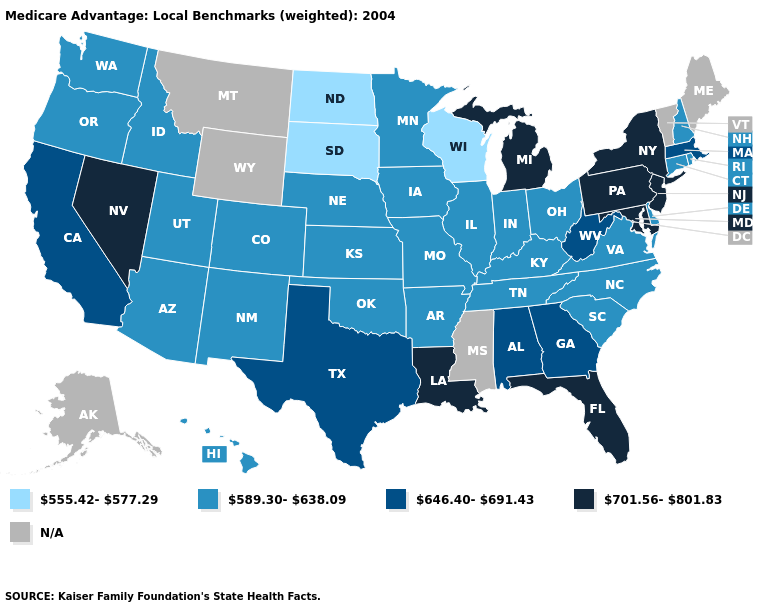What is the highest value in the USA?
Be succinct. 701.56-801.83. Which states have the lowest value in the MidWest?
Keep it brief. North Dakota, South Dakota, Wisconsin. Among the states that border Louisiana , which have the highest value?
Give a very brief answer. Texas. Name the states that have a value in the range 555.42-577.29?
Quick response, please. North Dakota, South Dakota, Wisconsin. What is the highest value in the USA?
Concise answer only. 701.56-801.83. What is the value of Delaware?
Keep it brief. 589.30-638.09. What is the lowest value in the West?
Be succinct. 589.30-638.09. What is the value of Maine?
Short answer required. N/A. What is the lowest value in states that border Massachusetts?
Short answer required. 589.30-638.09. How many symbols are there in the legend?
Quick response, please. 5. What is the highest value in the USA?
Quick response, please. 701.56-801.83. What is the highest value in states that border Georgia?
Quick response, please. 701.56-801.83. Which states have the lowest value in the West?
Give a very brief answer. Arizona, Colorado, Hawaii, Idaho, New Mexico, Oregon, Utah, Washington. 